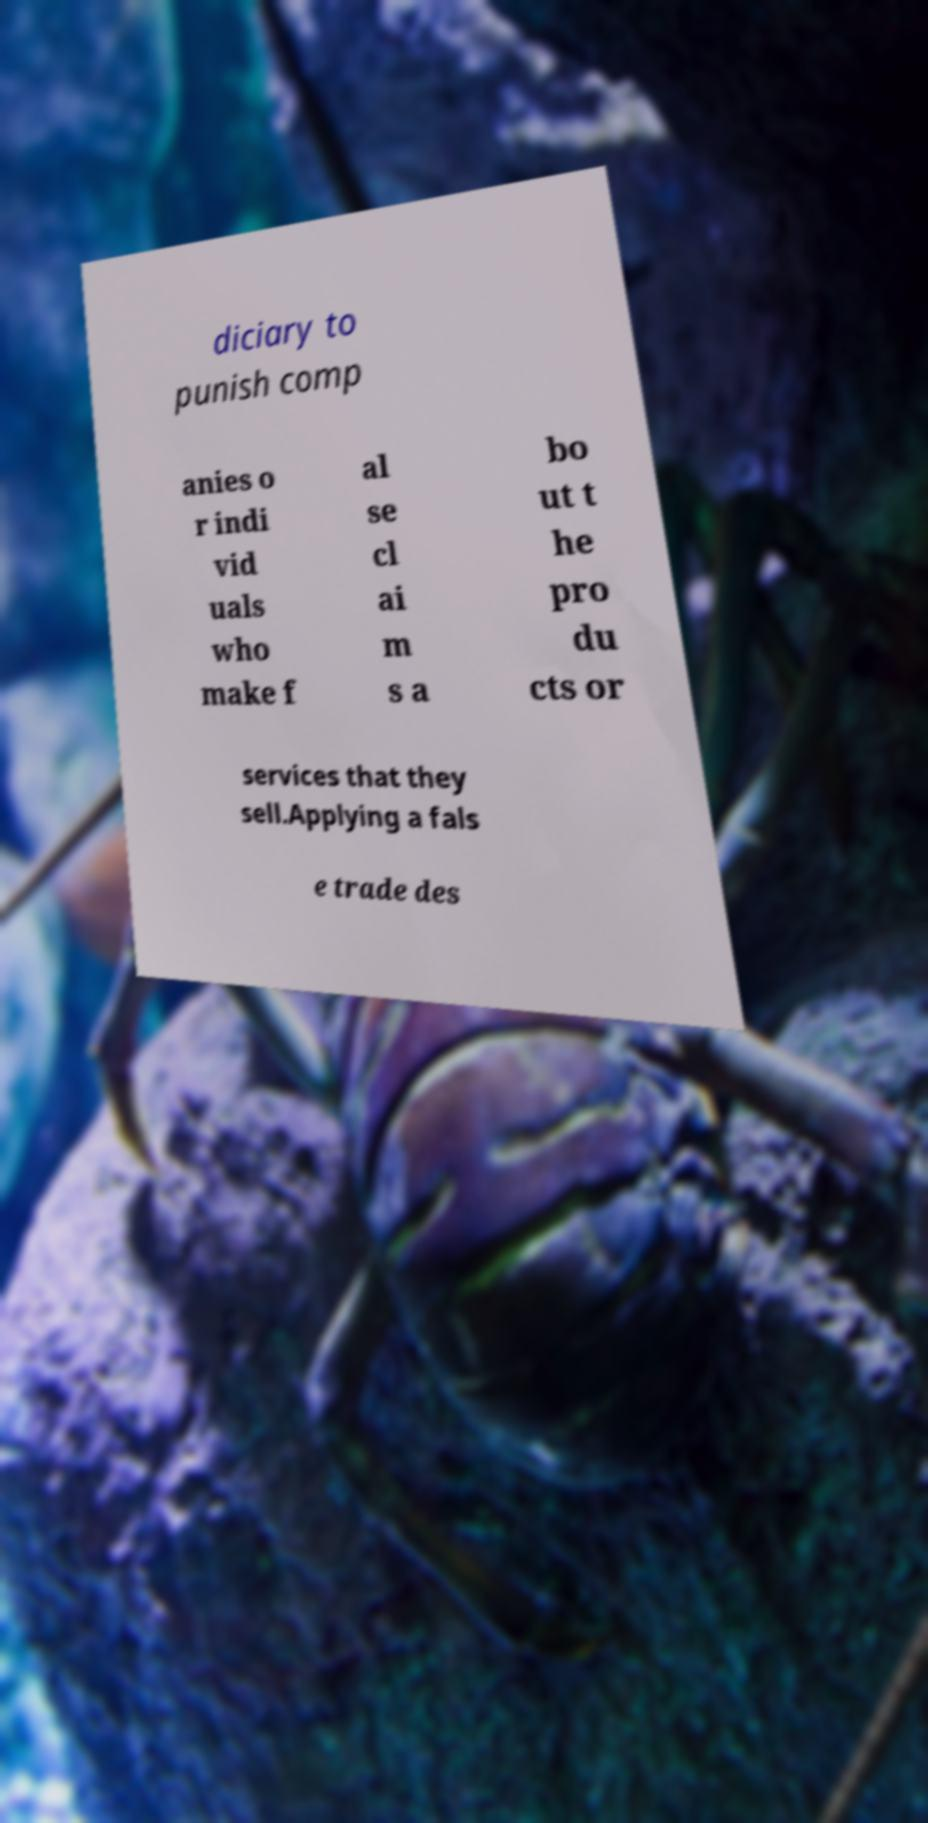Could you extract and type out the text from this image? diciary to punish comp anies o r indi vid uals who make f al se cl ai m s a bo ut t he pro du cts or services that they sell.Applying a fals e trade des 